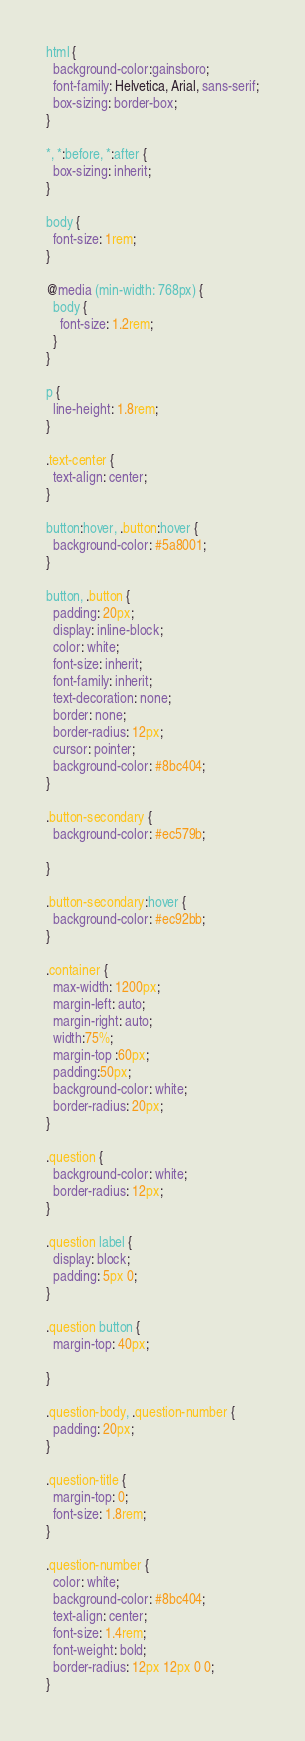<code> <loc_0><loc_0><loc_500><loc_500><_CSS_>html {
  background-color:gainsboro;
  font-family: Helvetica, Arial, sans-serif;
  box-sizing: border-box;
}

*, *:before, *:after {
  box-sizing: inherit;
}

body {
  font-size: 1rem;
}

@media (min-width: 768px) {
  body {
    font-size: 1.2rem;
  }
}

p {
  line-height: 1.8rem;
}

.text-center {
  text-align: center;
}

button:hover, .button:hover {
  background-color: #5a8001;
}

button, .button {
  padding: 20px;
  display: inline-block;
  color: white;
  font-size: inherit;
  font-family: inherit;
  text-decoration: none;
  border: none;
  border-radius: 12px;
  cursor: pointer;
  background-color: #8bc404;
}

.button-secondary {
  background-color: #ec579b;

}

.button-secondary:hover {
  background-color: #ec92bb;
}

.container {
  max-width: 1200px;
  margin-left: auto;
  margin-right: auto;
  width:75%;
  margin-top :60px;
  padding:50px;
  background-color: white;
  border-radius: 20px;
}

.question {
  background-color: white;
  border-radius: 12px;
}

.question label {
  display: block;
  padding: 5px 0;
}

.question button {
  margin-top: 40px;

}

.question-body, .question-number {
  padding: 20px;
}

.question-title {
  margin-top: 0;
  font-size: 1.8rem;
}

.question-number {
  color: white;
  background-color: #8bc404;
  text-align: center;
  font-size: 1.4rem;
  font-weight: bold;
  border-radius: 12px 12px 0 0;
}
</code> 